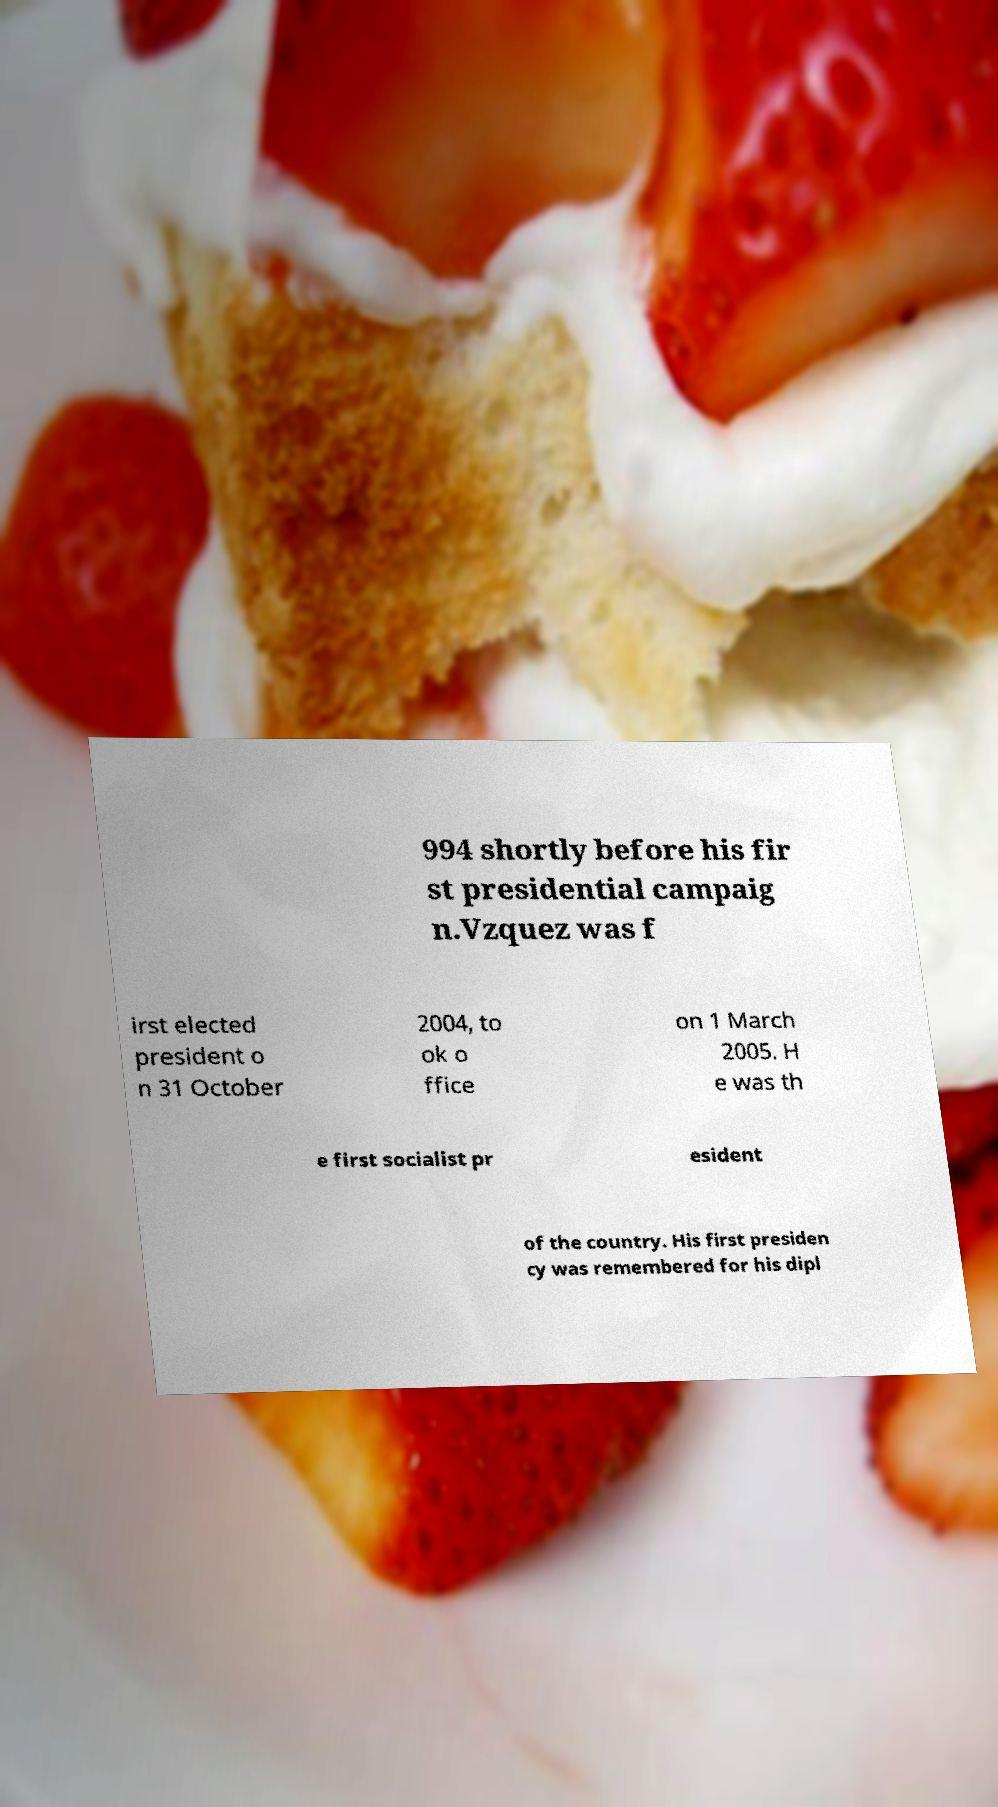Please read and relay the text visible in this image. What does it say? 994 shortly before his fir st presidential campaig n.Vzquez was f irst elected president o n 31 October 2004, to ok o ffice on 1 March 2005. H e was th e first socialist pr esident of the country. His first presiden cy was remembered for his dipl 